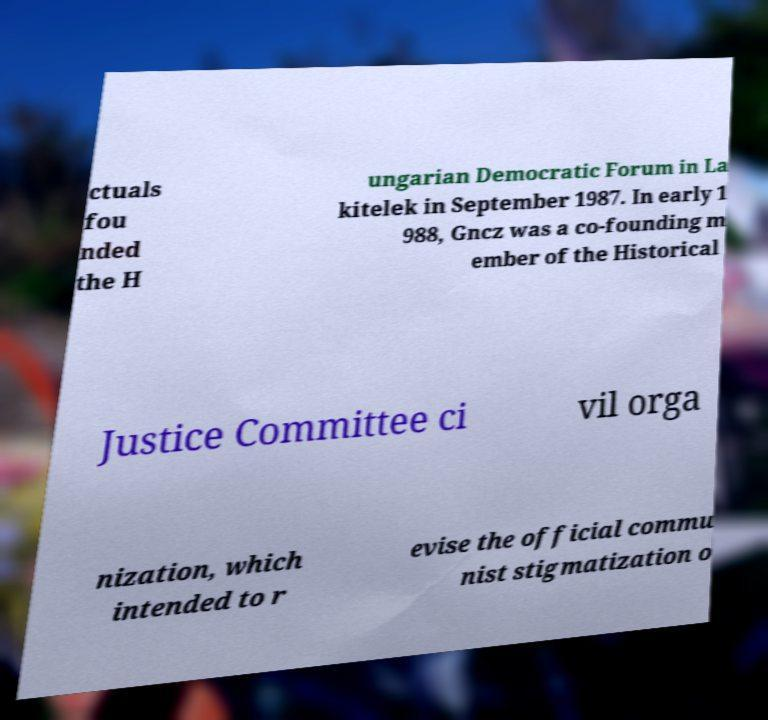What messages or text are displayed in this image? I need them in a readable, typed format. ctuals fou nded the H ungarian Democratic Forum in La kitelek in September 1987. In early 1 988, Gncz was a co-founding m ember of the Historical Justice Committee ci vil orga nization, which intended to r evise the official commu nist stigmatization o 